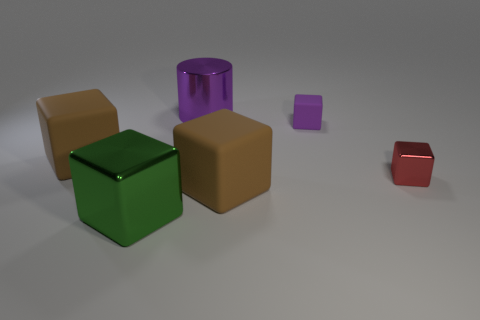Subtract all green cubes. How many cubes are left? 4 Subtract all blocks. How many objects are left? 1 Add 3 tiny yellow matte things. How many objects exist? 9 Subtract all green cubes. How many cubes are left? 4 Subtract all purple shiny cylinders. Subtract all big matte objects. How many objects are left? 3 Add 6 tiny rubber objects. How many tiny rubber objects are left? 7 Add 6 shiny cylinders. How many shiny cylinders exist? 7 Subtract 0 yellow balls. How many objects are left? 6 Subtract 1 cubes. How many cubes are left? 4 Subtract all blue cubes. Subtract all blue spheres. How many cubes are left? 5 